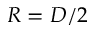Convert formula to latex. <formula><loc_0><loc_0><loc_500><loc_500>R = D / 2</formula> 